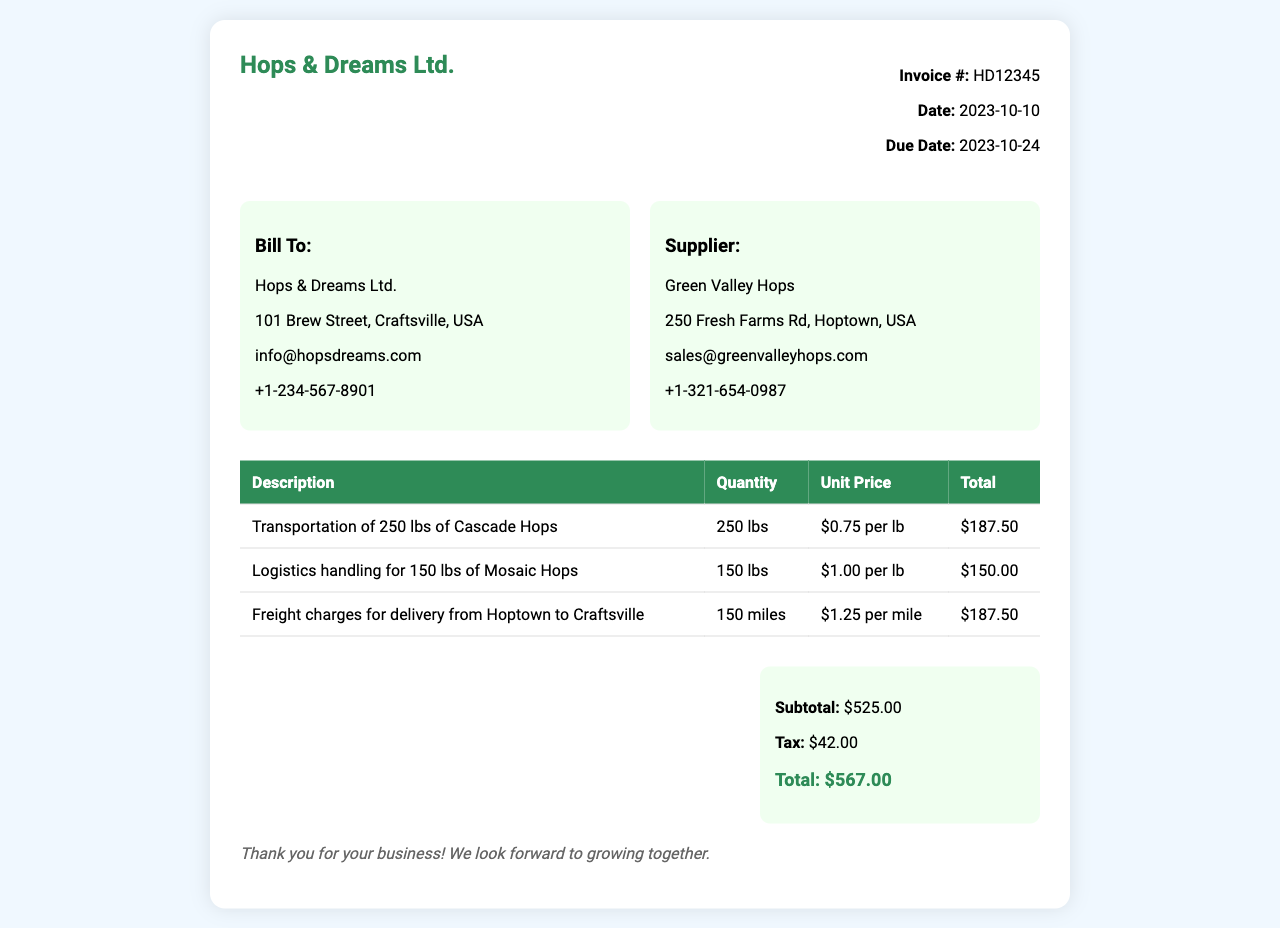What is the invoice number? The invoice number is specified in the document as HD12345.
Answer: HD12345 What is the date of the invoice? The invoice date is mentioned in the document as 2023-10-10.
Answer: 2023-10-10 Who is the supplier? The supplier's name is provided in the document as Green Valley Hops.
Answer: Green Valley Hops What is the total amount due? The total amount due is summarized at the end of the document, which is $567.00.
Answer: $567.00 How many pounds of Mosaic Hops are handled? The document specifies that logistics handling is for 150 lbs of Mosaic Hops.
Answer: 150 lbs What is the unit price for transportation of Cascade Hops? The unit price for transportation of Cascade Hops is given as $0.75 per lb.
Answer: $0.75 per lb How much is charged per mile for freight? The freight charge per mile is noted in the invoice as $1.25 per mile.
Answer: $1.25 per mile What is the subtotal listed in the invoice? The subtotal listed in the invoice is $525.00.
Answer: $525.00 How much tax is included in the total? The tax amount in the total is specified as $42.00.
Answer: $42.00 